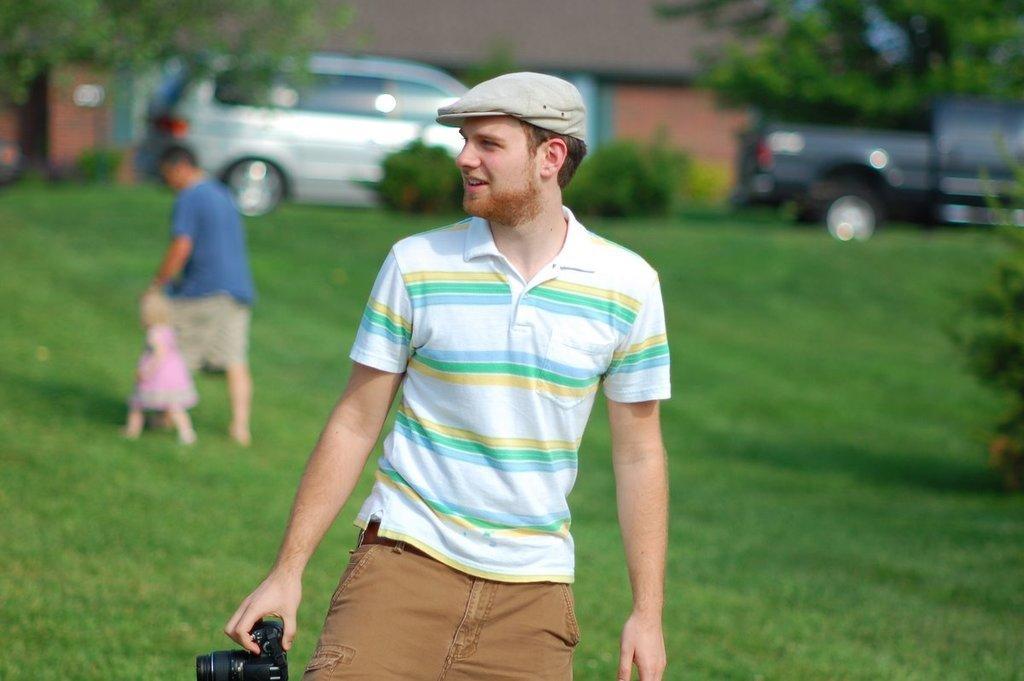In one or two sentences, can you explain what this image depicts? In this image I can see an open grass ground and on it I can see two persons and a girl. In the front I can see one person is holding a black colour camera and I can see he is wearing a cap. In the background I can see number of plants, trees, two vehicles and a building. I can also see this image is little bit blurry in the background. 